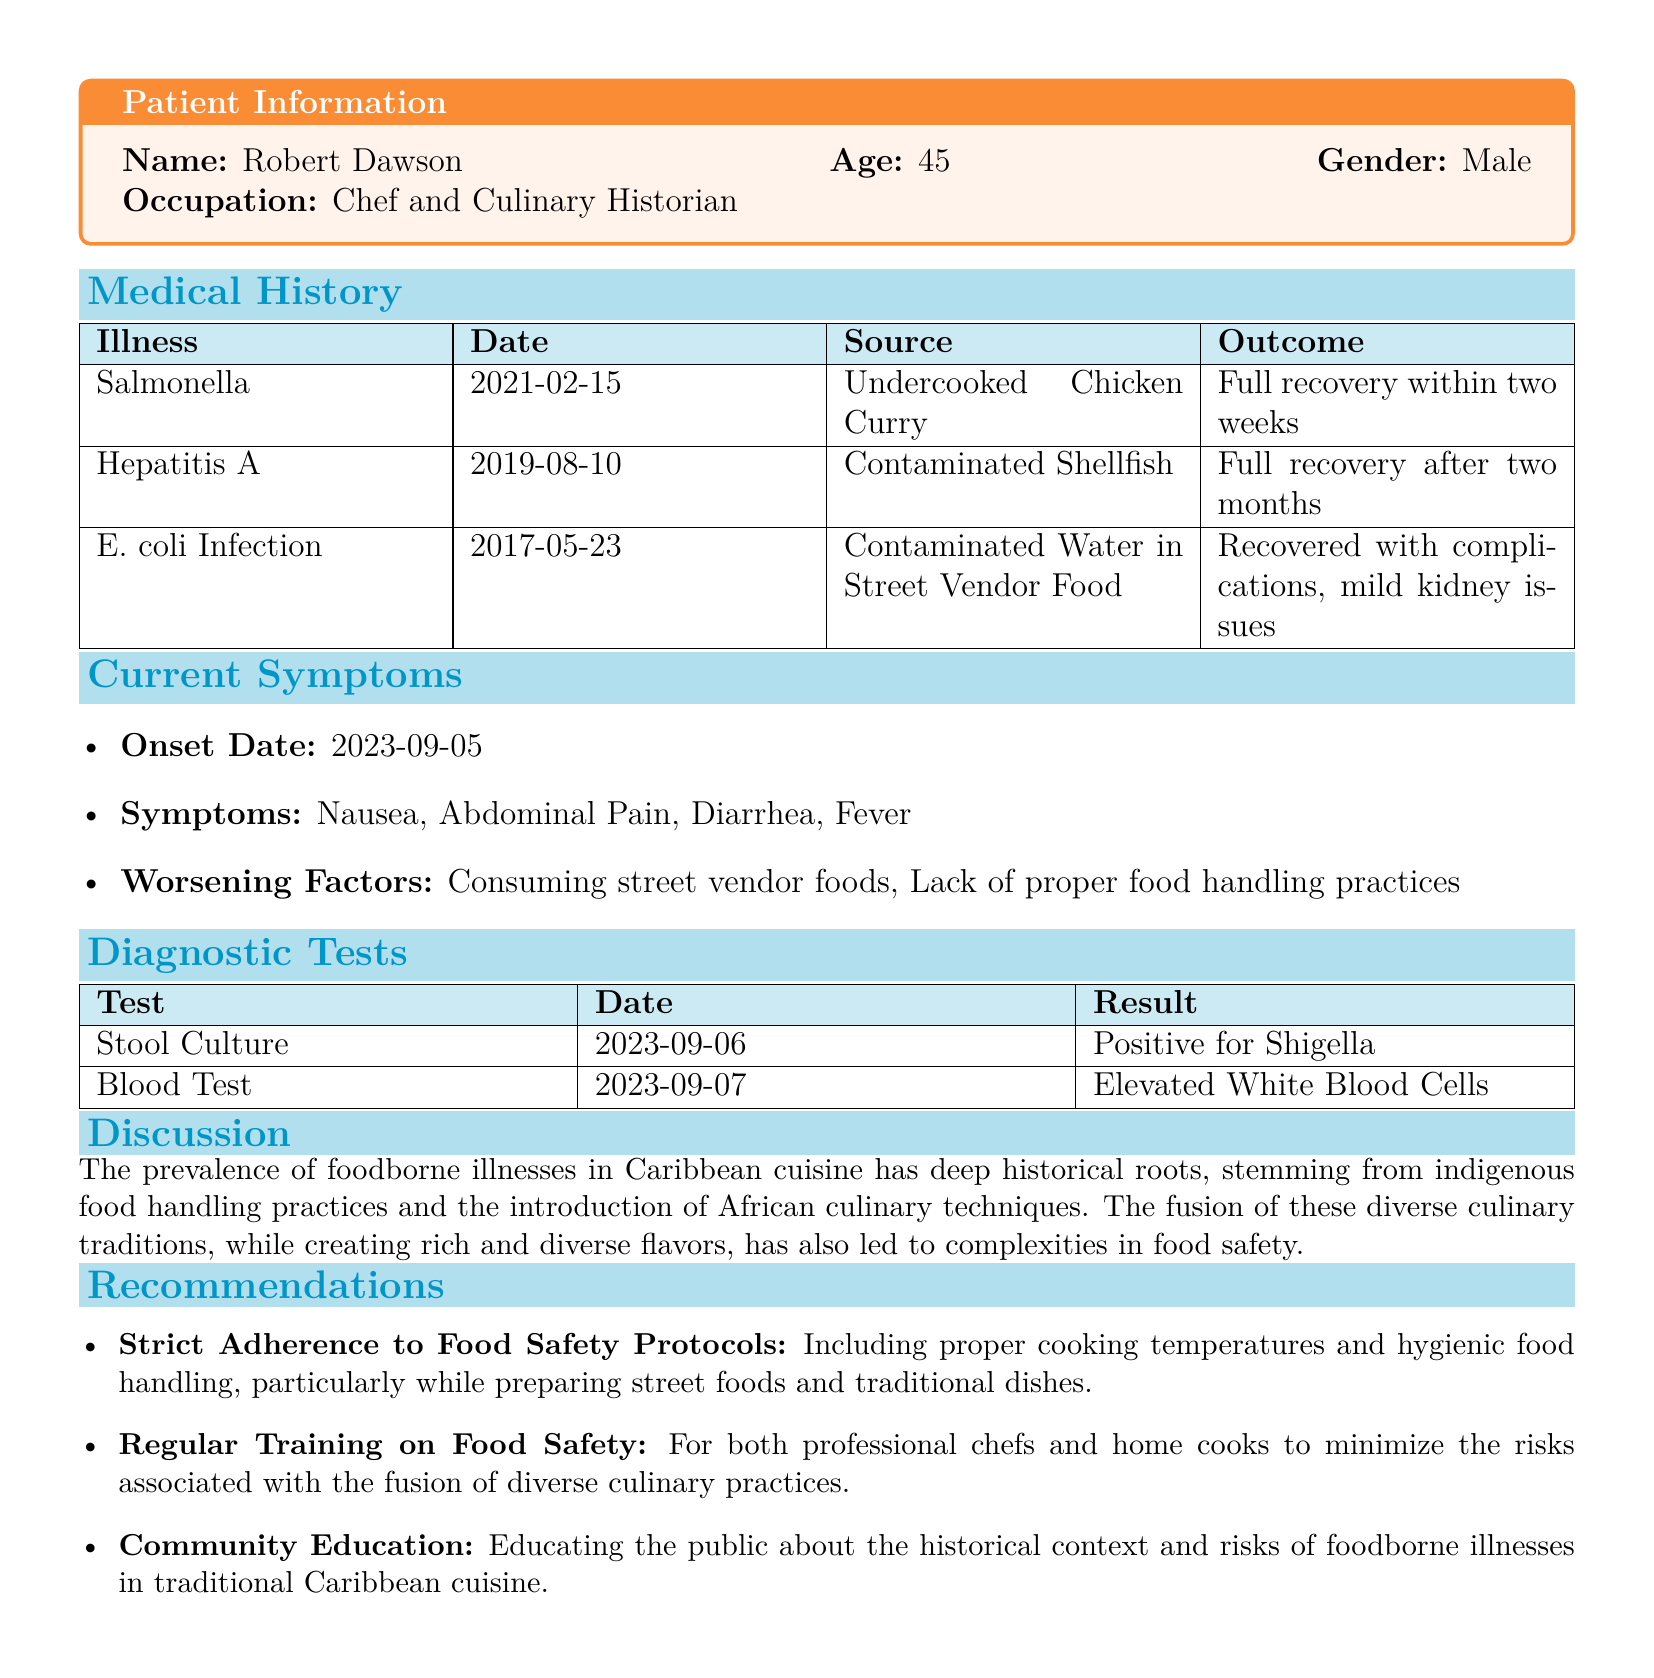what is the patient's name? The patient's name is provided in the patient information section.
Answer: Robert Dawson how old is the patient? The patient's age is included alongside their name in the patient information section.
Answer: 45 when was the stool culture test conducted? The date of the stool culture test is listed in the diagnostic tests section.
Answer: 2023-09-06 what illness did the patient recover from in two weeks? This information can be found in the medical history section regarding the patient's illnesses.
Answer: Salmonella what is a significant source of foodborne illness mentioned in the current symptoms? The document specifies contributing factors to the patient's symptoms in the current symptoms section.
Answer: Consuming street vendor foods what is one of the recommendations provided in the document? Several recommendations are listed in the recommendations section of the document.
Answer: Strict adherence to food safety protocols how many illnesses are listed in the medical history? By counting the illnesses mentioned in the medical history section, the answer can be determined.
Answer: 3 what historical fusion is discussed in the document concerning Caribbean cuisine? The discussion highlights the historical influences on Caribbean cuisine.
Answer: Indigenous food handling practices and African culinary techniques what test result indicated an elevated condition for the patient? This information is found in the diagnostic tests section regarding the blood test result.
Answer: Elevated White Blood Cells 